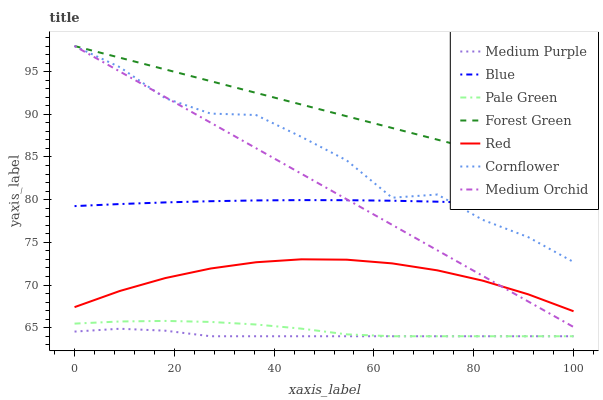Does Medium Purple have the minimum area under the curve?
Answer yes or no. Yes. Does Forest Green have the maximum area under the curve?
Answer yes or no. Yes. Does Cornflower have the minimum area under the curve?
Answer yes or no. No. Does Cornflower have the maximum area under the curve?
Answer yes or no. No. Is Forest Green the smoothest?
Answer yes or no. Yes. Is Cornflower the roughest?
Answer yes or no. Yes. Is Medium Orchid the smoothest?
Answer yes or no. No. Is Medium Orchid the roughest?
Answer yes or no. No. Does Medium Purple have the lowest value?
Answer yes or no. Yes. Does Cornflower have the lowest value?
Answer yes or no. No. Does Forest Green have the highest value?
Answer yes or no. Yes. Does Medium Purple have the highest value?
Answer yes or no. No. Is Red less than Forest Green?
Answer yes or no. Yes. Is Medium Orchid greater than Pale Green?
Answer yes or no. Yes. Does Forest Green intersect Medium Orchid?
Answer yes or no. Yes. Is Forest Green less than Medium Orchid?
Answer yes or no. No. Is Forest Green greater than Medium Orchid?
Answer yes or no. No. Does Red intersect Forest Green?
Answer yes or no. No. 